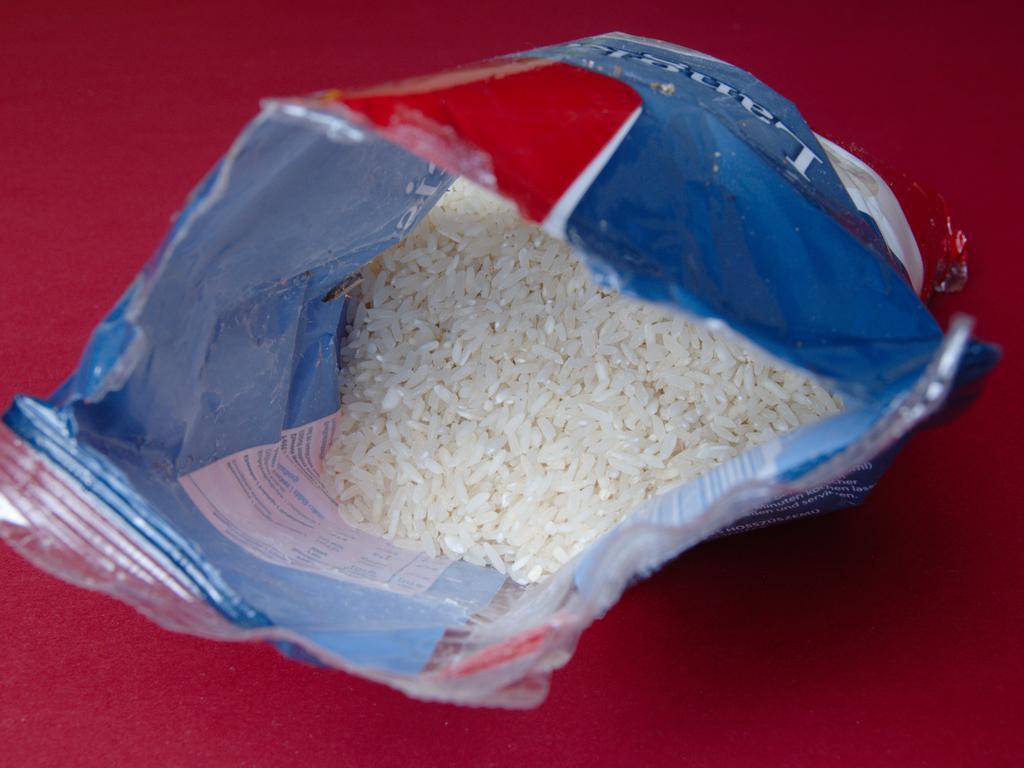In one or two sentences, can you explain what this image depicts? In this image there is a rice in a packet which was placed on a red colored surface. 